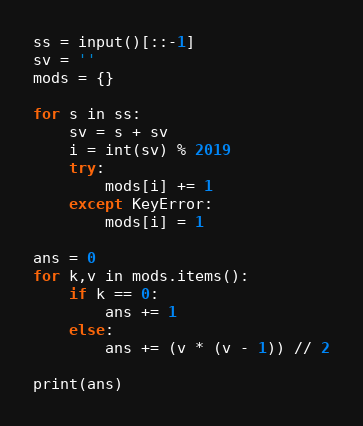<code> <loc_0><loc_0><loc_500><loc_500><_Python_>ss = input()[::-1]
sv = ''
mods = {}

for s in ss:
    sv = s + sv
    i = int(sv) % 2019
    try:
        mods[i] += 1
    except KeyError:
        mods[i] = 1

ans = 0
for k,v in mods.items():
    if k == 0:
        ans += 1
    else:
        ans += (v * (v - 1)) // 2

print(ans)</code> 